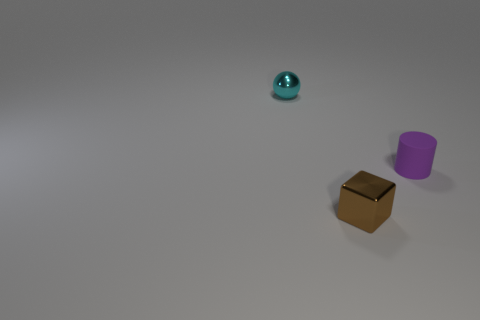Do the cyan thing and the small purple object have the same shape?
Offer a terse response. No. How many matte objects are either spheres or tiny gray cubes?
Your response must be concise. 0. What number of blue things are cylinders or tiny things?
Your answer should be very brief. 0. Do the brown object and the cylinder have the same material?
Your response must be concise. No. Is the number of small brown objects left of the ball the same as the number of tiny objects that are in front of the purple rubber object?
Your answer should be very brief. No. There is a shiny object that is in front of the metal object that is behind the small metallic thing right of the cyan metallic thing; what shape is it?
Your answer should be compact. Cube. Is the number of small brown metal objects that are in front of the small purple matte cylinder greater than the number of large yellow rubber cylinders?
Your answer should be compact. Yes. There is a tiny thing behind the small cylinder; what is it made of?
Your response must be concise. Metal. What is the material of the tiny thing on the right side of the metallic thing that is to the right of the cyan thing?
Offer a very short reply. Rubber. Is there a tiny block that has the same material as the cyan thing?
Provide a short and direct response. Yes. 